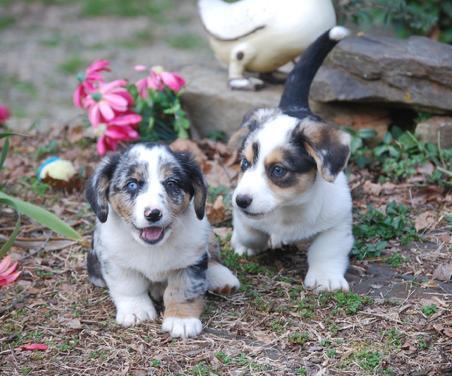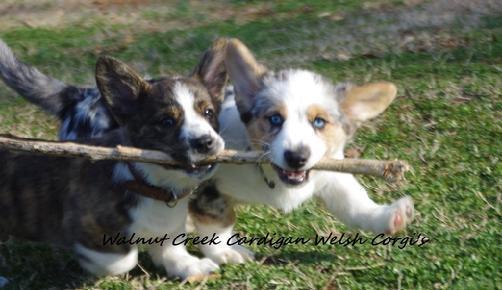The first image is the image on the left, the second image is the image on the right. For the images displayed, is the sentence "There are at most two dogs." factually correct? Answer yes or no. No. The first image is the image on the left, the second image is the image on the right. Evaluate the accuracy of this statement regarding the images: "There are exactly two dogs.". Is it true? Answer yes or no. No. 